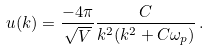<formula> <loc_0><loc_0><loc_500><loc_500>u ( { k } ) = \frac { - 4 \pi } { \sqrt { V } } \frac { C } { k ^ { 2 } ( k ^ { 2 } + C \omega _ { p } ) } \, .</formula> 